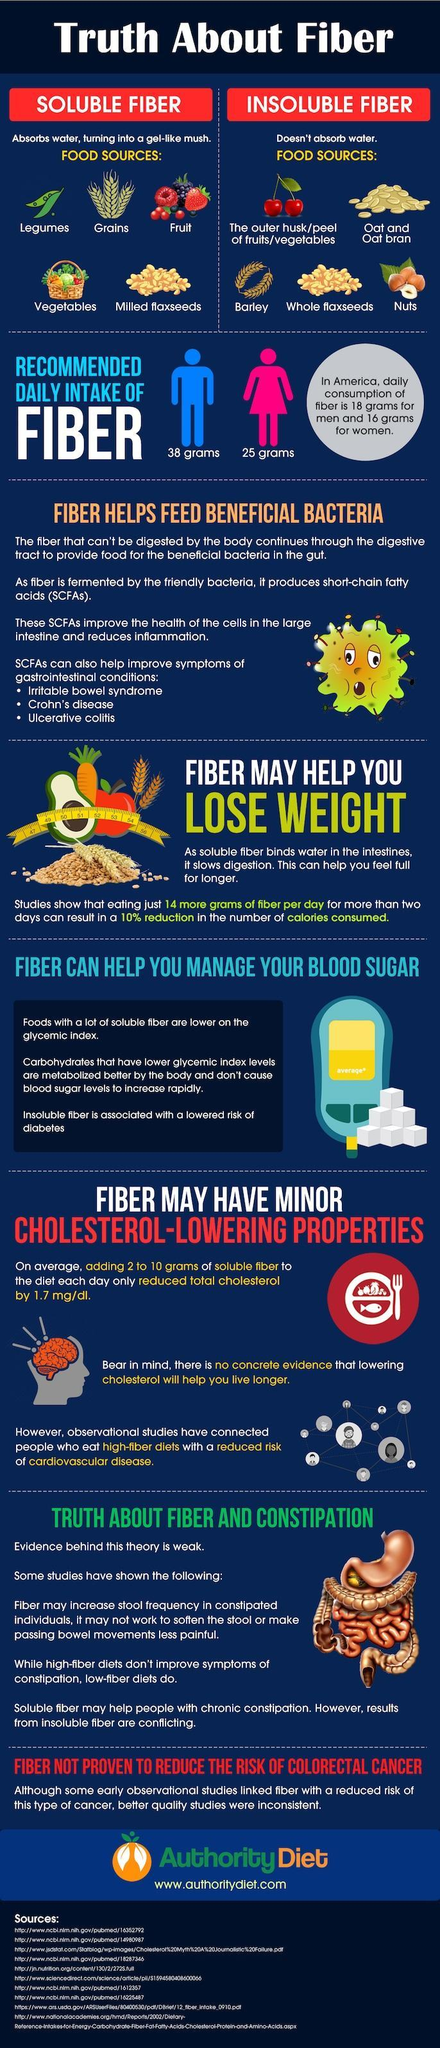Which gender has more recommended daily intake of fiber- men or women?
Answer the question with a short phrase. men How many sources are listed at the bottom? 10 What is the difference between daily intake and recommended intake of fibers for women in America? 9 grams 